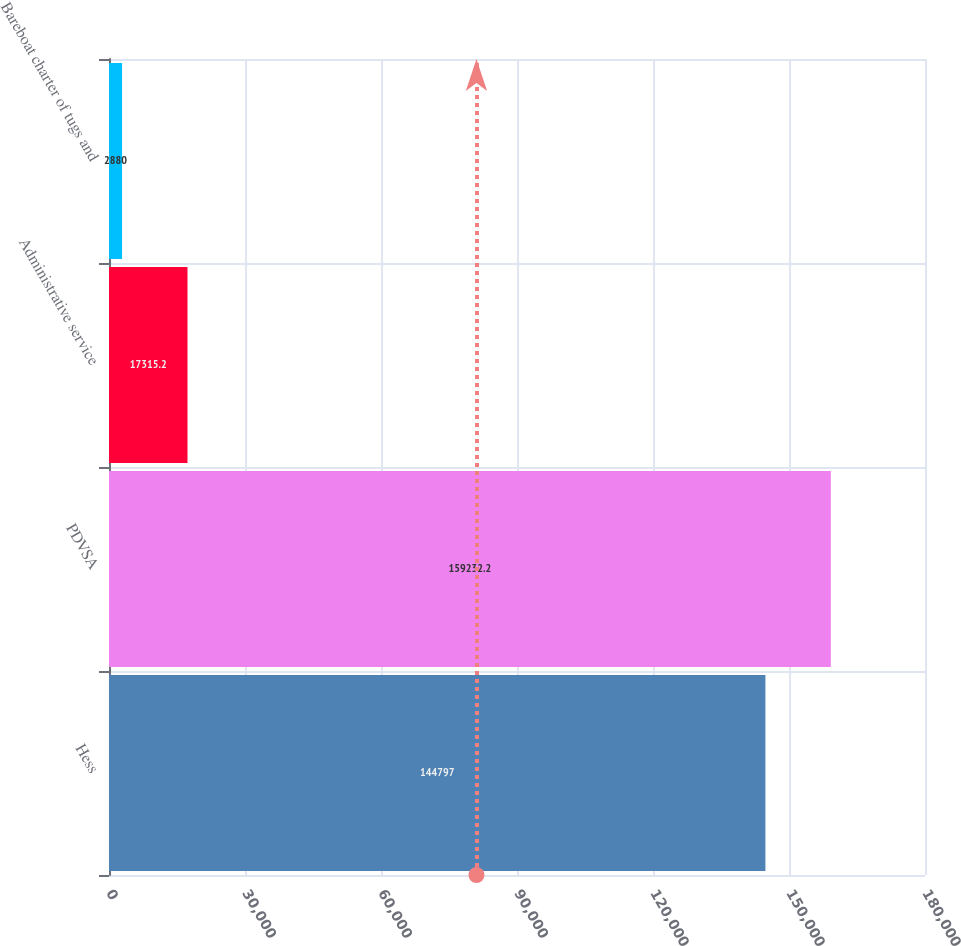<chart> <loc_0><loc_0><loc_500><loc_500><bar_chart><fcel>Hess<fcel>PDVSA<fcel>Administrative service<fcel>Bareboat charter of tugs and<nl><fcel>144797<fcel>159232<fcel>17315.2<fcel>2880<nl></chart> 